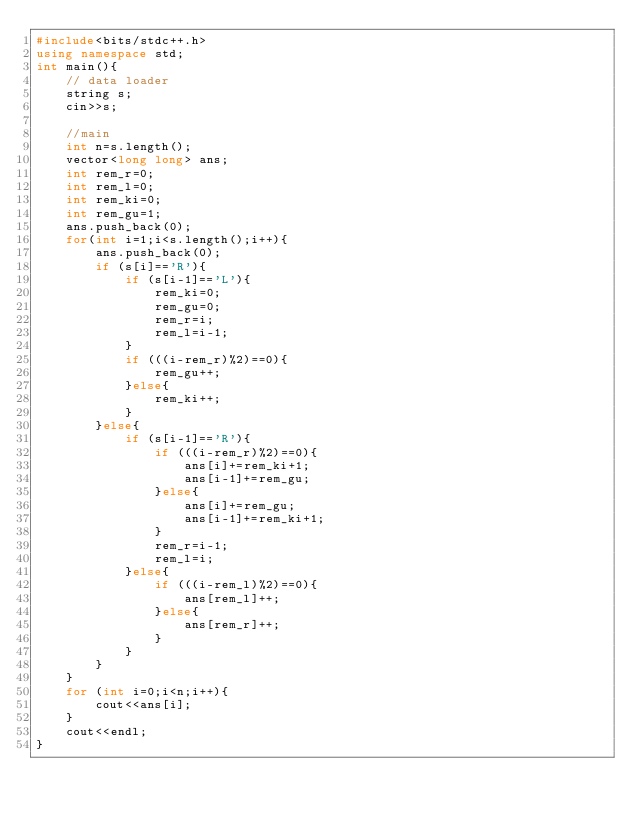<code> <loc_0><loc_0><loc_500><loc_500><_C++_>#include<bits/stdc++.h>
using namespace std;
int main(){
    // data loader
    string s;
    cin>>s;
    
    //main
    int n=s.length();
    vector<long long> ans;
    int rem_r=0;
    int rem_l=0;
    int rem_ki=0;
    int rem_gu=1;
    ans.push_back(0);
    for(int i=1;i<s.length();i++){
        ans.push_back(0);
        if (s[i]=='R'){
            if (s[i-1]=='L'){
                rem_ki=0;
                rem_gu=0;
                rem_r=i;
                rem_l=i-1;
            }
            if (((i-rem_r)%2)==0){
                rem_gu++;
            }else{
                rem_ki++;
            }
        }else{
            if (s[i-1]=='R'){
                if (((i-rem_r)%2)==0){
                    ans[i]+=rem_ki+1;
                    ans[i-1]+=rem_gu;
                }else{
                    ans[i]+=rem_gu;
                    ans[i-1]+=rem_ki+1;
                }
                rem_r=i-1;
                rem_l=i;
            }else{
                if (((i-rem_l)%2)==0){
                    ans[rem_l]++;
                }else{
                    ans[rem_r]++;
                }
            }
        }
    }
    for (int i=0;i<n;i++){
        cout<<ans[i];
    }
    cout<<endl;
}</code> 